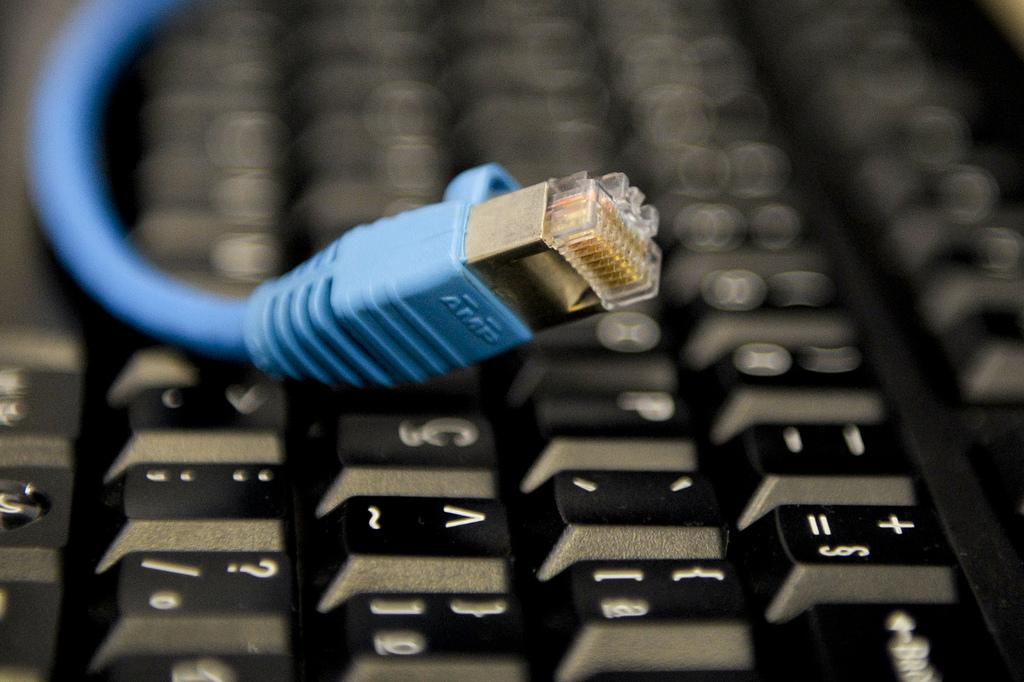<image>
Describe the image concisely. an Ethernet cord with the letters AMP, lays across a keyboard. 